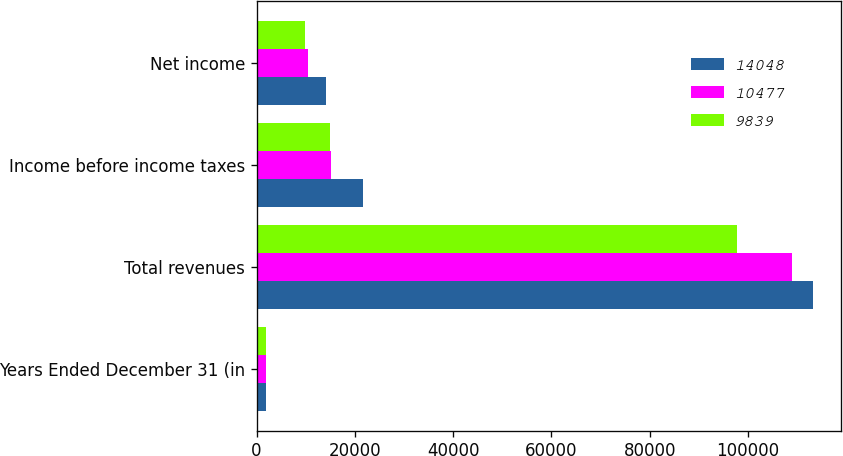<chart> <loc_0><loc_0><loc_500><loc_500><stacked_bar_chart><ecel><fcel>Years Ended December 31 (in<fcel>Total revenues<fcel>Income before income taxes<fcel>Net income<nl><fcel>14048<fcel>2006<fcel>113194<fcel>21687<fcel>14048<nl><fcel>10477<fcel>2005<fcel>108905<fcel>15213<fcel>10477<nl><fcel>9839<fcel>2004<fcel>97666<fcel>14845<fcel>9839<nl></chart> 